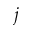<formula> <loc_0><loc_0><loc_500><loc_500>j</formula> 